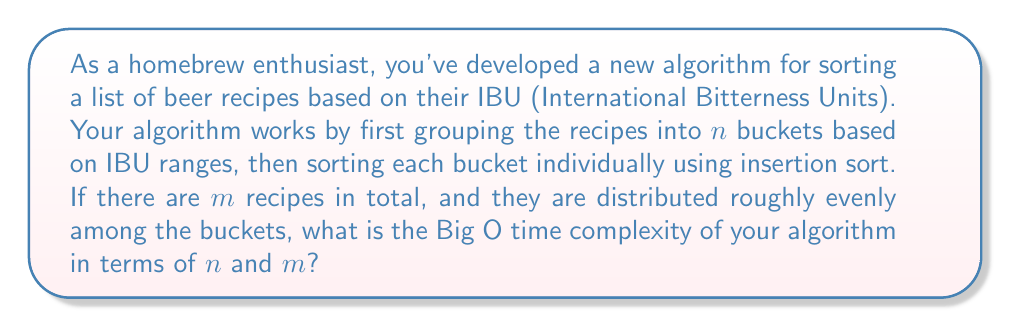Can you answer this question? Let's break this down step-by-step:

1) First, we need to consider the time complexity of grouping the recipes into buckets:
   - This operation requires going through all $m$ recipes once, so it's $O(m)$.

2) Next, we need to analyze the sorting of each bucket:
   - There are $n$ buckets.
   - Each bucket contains approximately $\frac{m}{n}$ recipes (assuming even distribution).
   - Insertion sort has a time complexity of $O(k^2)$ for $k$ elements.
   - So, sorting each bucket takes $O((\frac{m}{n})^2)$ time.

3) We perform this sorting for all $n$ buckets, so the total time for sorting is:
   $$ O(n \cdot (\frac{m}{n})^2) = O(\frac{m^2}{n}) $$

4) The total time complexity is the sum of the grouping step and the sorting step:
   $$ O(m) + O(\frac{m^2}{n}) $$

5) In Big O notation, we keep the term that grows the fastest. Here, it depends on the relative sizes of $m$ and $n$:
   - If $m > n^2$, then $\frac{m^2}{n}$ grows faster than $m$.
   - If $m \leq n^2$, then $m$ grows at least as fast as $\frac{m^2}{n}$.

6) Therefore, the overall time complexity is:
   $$ O(\max(m, \frac{m^2}{n})) $$

This notation means we take the larger of the two terms.
Answer: $O(\max(m, \frac{m^2}{n}))$ 